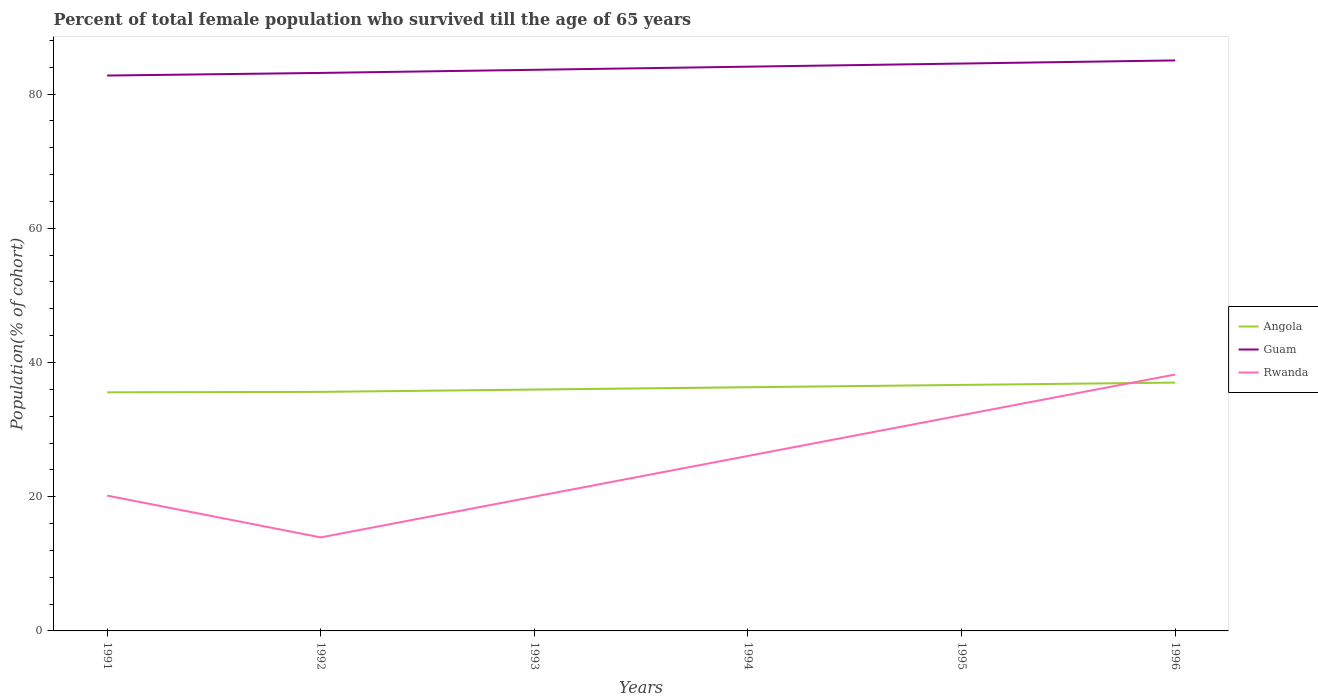Is the number of lines equal to the number of legend labels?
Ensure brevity in your answer.  Yes. Across all years, what is the maximum percentage of total female population who survived till the age of 65 years in Guam?
Your answer should be compact. 82.76. What is the total percentage of total female population who survived till the age of 65 years in Rwanda in the graph?
Your answer should be compact. 6.23. What is the difference between the highest and the second highest percentage of total female population who survived till the age of 65 years in Guam?
Ensure brevity in your answer.  2.25. What is the difference between the highest and the lowest percentage of total female population who survived till the age of 65 years in Rwanda?
Ensure brevity in your answer.  3. How many lines are there?
Offer a very short reply. 3. How many years are there in the graph?
Provide a succinct answer. 6. Are the values on the major ticks of Y-axis written in scientific E-notation?
Provide a short and direct response. No. How many legend labels are there?
Your response must be concise. 3. What is the title of the graph?
Offer a terse response. Percent of total female population who survived till the age of 65 years. What is the label or title of the Y-axis?
Give a very brief answer. Population(% of cohort). What is the Population(% of cohort) in Angola in 1991?
Provide a succinct answer. 35.56. What is the Population(% of cohort) in Guam in 1991?
Your answer should be very brief. 82.76. What is the Population(% of cohort) in Rwanda in 1991?
Offer a very short reply. 20.17. What is the Population(% of cohort) in Angola in 1992?
Offer a very short reply. 35.62. What is the Population(% of cohort) of Guam in 1992?
Your answer should be very brief. 83.16. What is the Population(% of cohort) of Rwanda in 1992?
Offer a very short reply. 13.94. What is the Population(% of cohort) in Angola in 1993?
Offer a terse response. 35.97. What is the Population(% of cohort) of Guam in 1993?
Keep it short and to the point. 83.62. What is the Population(% of cohort) in Rwanda in 1993?
Make the answer very short. 20.01. What is the Population(% of cohort) in Angola in 1994?
Your response must be concise. 36.32. What is the Population(% of cohort) in Guam in 1994?
Your response must be concise. 84.09. What is the Population(% of cohort) of Rwanda in 1994?
Offer a terse response. 26.08. What is the Population(% of cohort) in Angola in 1995?
Ensure brevity in your answer.  36.66. What is the Population(% of cohort) in Guam in 1995?
Your response must be concise. 84.55. What is the Population(% of cohort) in Rwanda in 1995?
Make the answer very short. 32.15. What is the Population(% of cohort) of Angola in 1996?
Give a very brief answer. 37.01. What is the Population(% of cohort) in Guam in 1996?
Ensure brevity in your answer.  85.02. What is the Population(% of cohort) of Rwanda in 1996?
Make the answer very short. 38.22. Across all years, what is the maximum Population(% of cohort) in Angola?
Make the answer very short. 37.01. Across all years, what is the maximum Population(% of cohort) in Guam?
Keep it short and to the point. 85.02. Across all years, what is the maximum Population(% of cohort) of Rwanda?
Ensure brevity in your answer.  38.22. Across all years, what is the minimum Population(% of cohort) of Angola?
Your answer should be compact. 35.56. Across all years, what is the minimum Population(% of cohort) of Guam?
Offer a very short reply. 82.76. Across all years, what is the minimum Population(% of cohort) of Rwanda?
Offer a terse response. 13.94. What is the total Population(% of cohort) of Angola in the graph?
Your answer should be very brief. 217.13. What is the total Population(% of cohort) of Guam in the graph?
Provide a succinct answer. 503.2. What is the total Population(% of cohort) of Rwanda in the graph?
Ensure brevity in your answer.  150.55. What is the difference between the Population(% of cohort) in Angola in 1991 and that in 1992?
Ensure brevity in your answer.  -0.07. What is the difference between the Population(% of cohort) of Guam in 1991 and that in 1992?
Give a very brief answer. -0.39. What is the difference between the Population(% of cohort) of Rwanda in 1991 and that in 1992?
Offer a very short reply. 6.23. What is the difference between the Population(% of cohort) of Angola in 1991 and that in 1993?
Offer a very short reply. -0.41. What is the difference between the Population(% of cohort) of Guam in 1991 and that in 1993?
Give a very brief answer. -0.86. What is the difference between the Population(% of cohort) in Rwanda in 1991 and that in 1993?
Offer a very short reply. 0.16. What is the difference between the Population(% of cohort) of Angola in 1991 and that in 1994?
Offer a terse response. -0.76. What is the difference between the Population(% of cohort) of Guam in 1991 and that in 1994?
Keep it short and to the point. -1.32. What is the difference between the Population(% of cohort) in Rwanda in 1991 and that in 1994?
Make the answer very short. -5.91. What is the difference between the Population(% of cohort) of Angola in 1991 and that in 1995?
Your response must be concise. -1.11. What is the difference between the Population(% of cohort) in Guam in 1991 and that in 1995?
Provide a short and direct response. -1.79. What is the difference between the Population(% of cohort) in Rwanda in 1991 and that in 1995?
Provide a short and direct response. -11.98. What is the difference between the Population(% of cohort) in Angola in 1991 and that in 1996?
Provide a succinct answer. -1.45. What is the difference between the Population(% of cohort) in Guam in 1991 and that in 1996?
Give a very brief answer. -2.25. What is the difference between the Population(% of cohort) in Rwanda in 1991 and that in 1996?
Make the answer very short. -18.05. What is the difference between the Population(% of cohort) of Angola in 1992 and that in 1993?
Offer a very short reply. -0.35. What is the difference between the Population(% of cohort) in Guam in 1992 and that in 1993?
Your answer should be compact. -0.47. What is the difference between the Population(% of cohort) of Rwanda in 1992 and that in 1993?
Make the answer very short. -6.07. What is the difference between the Population(% of cohort) in Angola in 1992 and that in 1994?
Your answer should be very brief. -0.69. What is the difference between the Population(% of cohort) of Guam in 1992 and that in 1994?
Give a very brief answer. -0.93. What is the difference between the Population(% of cohort) of Rwanda in 1992 and that in 1994?
Give a very brief answer. -12.14. What is the difference between the Population(% of cohort) in Angola in 1992 and that in 1995?
Your answer should be compact. -1.04. What is the difference between the Population(% of cohort) in Guam in 1992 and that in 1995?
Make the answer very short. -1.4. What is the difference between the Population(% of cohort) of Rwanda in 1992 and that in 1995?
Offer a terse response. -18.21. What is the difference between the Population(% of cohort) in Angola in 1992 and that in 1996?
Your answer should be compact. -1.38. What is the difference between the Population(% of cohort) in Guam in 1992 and that in 1996?
Offer a terse response. -1.86. What is the difference between the Population(% of cohort) of Rwanda in 1992 and that in 1996?
Provide a short and direct response. -24.28. What is the difference between the Population(% of cohort) of Angola in 1993 and that in 1994?
Your answer should be very brief. -0.35. What is the difference between the Population(% of cohort) in Guam in 1993 and that in 1994?
Offer a terse response. -0.47. What is the difference between the Population(% of cohort) of Rwanda in 1993 and that in 1994?
Give a very brief answer. -6.07. What is the difference between the Population(% of cohort) of Angola in 1993 and that in 1995?
Your answer should be compact. -0.69. What is the difference between the Population(% of cohort) in Guam in 1993 and that in 1995?
Offer a terse response. -0.93. What is the difference between the Population(% of cohort) in Rwanda in 1993 and that in 1995?
Make the answer very short. -12.14. What is the difference between the Population(% of cohort) of Angola in 1993 and that in 1996?
Keep it short and to the point. -1.04. What is the difference between the Population(% of cohort) in Guam in 1993 and that in 1996?
Provide a succinct answer. -1.4. What is the difference between the Population(% of cohort) in Rwanda in 1993 and that in 1996?
Make the answer very short. -18.21. What is the difference between the Population(% of cohort) in Angola in 1994 and that in 1995?
Keep it short and to the point. -0.35. What is the difference between the Population(% of cohort) in Guam in 1994 and that in 1995?
Offer a terse response. -0.47. What is the difference between the Population(% of cohort) of Rwanda in 1994 and that in 1995?
Make the answer very short. -6.07. What is the difference between the Population(% of cohort) in Angola in 1994 and that in 1996?
Your answer should be compact. -0.69. What is the difference between the Population(% of cohort) of Guam in 1994 and that in 1996?
Provide a succinct answer. -0.93. What is the difference between the Population(% of cohort) in Rwanda in 1994 and that in 1996?
Provide a succinct answer. -12.14. What is the difference between the Population(% of cohort) in Angola in 1995 and that in 1996?
Provide a succinct answer. -0.35. What is the difference between the Population(% of cohort) in Guam in 1995 and that in 1996?
Offer a very short reply. -0.47. What is the difference between the Population(% of cohort) in Rwanda in 1995 and that in 1996?
Keep it short and to the point. -6.07. What is the difference between the Population(% of cohort) of Angola in 1991 and the Population(% of cohort) of Guam in 1992?
Keep it short and to the point. -47.6. What is the difference between the Population(% of cohort) of Angola in 1991 and the Population(% of cohort) of Rwanda in 1992?
Ensure brevity in your answer.  21.62. What is the difference between the Population(% of cohort) in Guam in 1991 and the Population(% of cohort) in Rwanda in 1992?
Give a very brief answer. 68.83. What is the difference between the Population(% of cohort) of Angola in 1991 and the Population(% of cohort) of Guam in 1993?
Provide a succinct answer. -48.07. What is the difference between the Population(% of cohort) in Angola in 1991 and the Population(% of cohort) in Rwanda in 1993?
Your answer should be very brief. 15.55. What is the difference between the Population(% of cohort) of Guam in 1991 and the Population(% of cohort) of Rwanda in 1993?
Your answer should be compact. 62.76. What is the difference between the Population(% of cohort) in Angola in 1991 and the Population(% of cohort) in Guam in 1994?
Your answer should be compact. -48.53. What is the difference between the Population(% of cohort) of Angola in 1991 and the Population(% of cohort) of Rwanda in 1994?
Give a very brief answer. 9.48. What is the difference between the Population(% of cohort) of Guam in 1991 and the Population(% of cohort) of Rwanda in 1994?
Offer a terse response. 56.69. What is the difference between the Population(% of cohort) in Angola in 1991 and the Population(% of cohort) in Guam in 1995?
Your answer should be very brief. -49. What is the difference between the Population(% of cohort) in Angola in 1991 and the Population(% of cohort) in Rwanda in 1995?
Offer a terse response. 3.41. What is the difference between the Population(% of cohort) of Guam in 1991 and the Population(% of cohort) of Rwanda in 1995?
Keep it short and to the point. 50.62. What is the difference between the Population(% of cohort) of Angola in 1991 and the Population(% of cohort) of Guam in 1996?
Give a very brief answer. -49.46. What is the difference between the Population(% of cohort) of Angola in 1991 and the Population(% of cohort) of Rwanda in 1996?
Your answer should be compact. -2.66. What is the difference between the Population(% of cohort) in Guam in 1991 and the Population(% of cohort) in Rwanda in 1996?
Offer a terse response. 44.55. What is the difference between the Population(% of cohort) of Angola in 1992 and the Population(% of cohort) of Guam in 1993?
Make the answer very short. -48. What is the difference between the Population(% of cohort) in Angola in 1992 and the Population(% of cohort) in Rwanda in 1993?
Offer a very short reply. 15.62. What is the difference between the Population(% of cohort) of Guam in 1992 and the Population(% of cohort) of Rwanda in 1993?
Your response must be concise. 63.15. What is the difference between the Population(% of cohort) in Angola in 1992 and the Population(% of cohort) in Guam in 1994?
Your answer should be very brief. -48.46. What is the difference between the Population(% of cohort) of Angola in 1992 and the Population(% of cohort) of Rwanda in 1994?
Your answer should be compact. 9.55. What is the difference between the Population(% of cohort) of Guam in 1992 and the Population(% of cohort) of Rwanda in 1994?
Offer a terse response. 57.08. What is the difference between the Population(% of cohort) of Angola in 1992 and the Population(% of cohort) of Guam in 1995?
Provide a succinct answer. -48.93. What is the difference between the Population(% of cohort) of Angola in 1992 and the Population(% of cohort) of Rwanda in 1995?
Keep it short and to the point. 3.48. What is the difference between the Population(% of cohort) in Guam in 1992 and the Population(% of cohort) in Rwanda in 1995?
Offer a very short reply. 51.01. What is the difference between the Population(% of cohort) of Angola in 1992 and the Population(% of cohort) of Guam in 1996?
Ensure brevity in your answer.  -49.39. What is the difference between the Population(% of cohort) in Angola in 1992 and the Population(% of cohort) in Rwanda in 1996?
Provide a succinct answer. -2.59. What is the difference between the Population(% of cohort) in Guam in 1992 and the Population(% of cohort) in Rwanda in 1996?
Offer a terse response. 44.94. What is the difference between the Population(% of cohort) in Angola in 1993 and the Population(% of cohort) in Guam in 1994?
Offer a terse response. -48.12. What is the difference between the Population(% of cohort) in Angola in 1993 and the Population(% of cohort) in Rwanda in 1994?
Your answer should be very brief. 9.89. What is the difference between the Population(% of cohort) of Guam in 1993 and the Population(% of cohort) of Rwanda in 1994?
Give a very brief answer. 57.54. What is the difference between the Population(% of cohort) in Angola in 1993 and the Population(% of cohort) in Guam in 1995?
Provide a succinct answer. -48.58. What is the difference between the Population(% of cohort) of Angola in 1993 and the Population(% of cohort) of Rwanda in 1995?
Offer a terse response. 3.82. What is the difference between the Population(% of cohort) of Guam in 1993 and the Population(% of cohort) of Rwanda in 1995?
Give a very brief answer. 51.47. What is the difference between the Population(% of cohort) of Angola in 1993 and the Population(% of cohort) of Guam in 1996?
Give a very brief answer. -49.05. What is the difference between the Population(% of cohort) in Angola in 1993 and the Population(% of cohort) in Rwanda in 1996?
Offer a terse response. -2.25. What is the difference between the Population(% of cohort) of Guam in 1993 and the Population(% of cohort) of Rwanda in 1996?
Your answer should be very brief. 45.41. What is the difference between the Population(% of cohort) in Angola in 1994 and the Population(% of cohort) in Guam in 1995?
Your response must be concise. -48.24. What is the difference between the Population(% of cohort) of Angola in 1994 and the Population(% of cohort) of Rwanda in 1995?
Offer a very short reply. 4.17. What is the difference between the Population(% of cohort) in Guam in 1994 and the Population(% of cohort) in Rwanda in 1995?
Provide a succinct answer. 51.94. What is the difference between the Population(% of cohort) in Angola in 1994 and the Population(% of cohort) in Guam in 1996?
Ensure brevity in your answer.  -48.7. What is the difference between the Population(% of cohort) in Angola in 1994 and the Population(% of cohort) in Rwanda in 1996?
Give a very brief answer. -1.9. What is the difference between the Population(% of cohort) of Guam in 1994 and the Population(% of cohort) of Rwanda in 1996?
Provide a succinct answer. 45.87. What is the difference between the Population(% of cohort) in Angola in 1995 and the Population(% of cohort) in Guam in 1996?
Offer a terse response. -48.36. What is the difference between the Population(% of cohort) of Angola in 1995 and the Population(% of cohort) of Rwanda in 1996?
Offer a terse response. -1.55. What is the difference between the Population(% of cohort) of Guam in 1995 and the Population(% of cohort) of Rwanda in 1996?
Your answer should be compact. 46.34. What is the average Population(% of cohort) of Angola per year?
Your response must be concise. 36.19. What is the average Population(% of cohort) of Guam per year?
Keep it short and to the point. 83.87. What is the average Population(% of cohort) of Rwanda per year?
Offer a very short reply. 25.09. In the year 1991, what is the difference between the Population(% of cohort) in Angola and Population(% of cohort) in Guam?
Provide a succinct answer. -47.21. In the year 1991, what is the difference between the Population(% of cohort) in Angola and Population(% of cohort) in Rwanda?
Offer a terse response. 15.39. In the year 1991, what is the difference between the Population(% of cohort) of Guam and Population(% of cohort) of Rwanda?
Make the answer very short. 62.6. In the year 1992, what is the difference between the Population(% of cohort) in Angola and Population(% of cohort) in Guam?
Offer a very short reply. -47.53. In the year 1992, what is the difference between the Population(% of cohort) in Angola and Population(% of cohort) in Rwanda?
Ensure brevity in your answer.  21.69. In the year 1992, what is the difference between the Population(% of cohort) of Guam and Population(% of cohort) of Rwanda?
Your answer should be compact. 69.22. In the year 1993, what is the difference between the Population(% of cohort) in Angola and Population(% of cohort) in Guam?
Make the answer very short. -47.65. In the year 1993, what is the difference between the Population(% of cohort) of Angola and Population(% of cohort) of Rwanda?
Offer a very short reply. 15.96. In the year 1993, what is the difference between the Population(% of cohort) in Guam and Population(% of cohort) in Rwanda?
Provide a succinct answer. 63.61. In the year 1994, what is the difference between the Population(% of cohort) in Angola and Population(% of cohort) in Guam?
Make the answer very short. -47.77. In the year 1994, what is the difference between the Population(% of cohort) in Angola and Population(% of cohort) in Rwanda?
Keep it short and to the point. 10.24. In the year 1994, what is the difference between the Population(% of cohort) in Guam and Population(% of cohort) in Rwanda?
Your answer should be compact. 58.01. In the year 1995, what is the difference between the Population(% of cohort) in Angola and Population(% of cohort) in Guam?
Make the answer very short. -47.89. In the year 1995, what is the difference between the Population(% of cohort) of Angola and Population(% of cohort) of Rwanda?
Ensure brevity in your answer.  4.51. In the year 1995, what is the difference between the Population(% of cohort) of Guam and Population(% of cohort) of Rwanda?
Your answer should be compact. 52.41. In the year 1996, what is the difference between the Population(% of cohort) in Angola and Population(% of cohort) in Guam?
Offer a terse response. -48.01. In the year 1996, what is the difference between the Population(% of cohort) of Angola and Population(% of cohort) of Rwanda?
Make the answer very short. -1.21. In the year 1996, what is the difference between the Population(% of cohort) in Guam and Population(% of cohort) in Rwanda?
Give a very brief answer. 46.8. What is the ratio of the Population(% of cohort) in Rwanda in 1991 to that in 1992?
Offer a terse response. 1.45. What is the ratio of the Population(% of cohort) in Angola in 1991 to that in 1993?
Keep it short and to the point. 0.99. What is the ratio of the Population(% of cohort) of Rwanda in 1991 to that in 1993?
Ensure brevity in your answer.  1.01. What is the ratio of the Population(% of cohort) of Angola in 1991 to that in 1994?
Provide a short and direct response. 0.98. What is the ratio of the Population(% of cohort) in Guam in 1991 to that in 1994?
Your answer should be very brief. 0.98. What is the ratio of the Population(% of cohort) in Rwanda in 1991 to that in 1994?
Offer a very short reply. 0.77. What is the ratio of the Population(% of cohort) in Angola in 1991 to that in 1995?
Offer a terse response. 0.97. What is the ratio of the Population(% of cohort) of Guam in 1991 to that in 1995?
Offer a very short reply. 0.98. What is the ratio of the Population(% of cohort) in Rwanda in 1991 to that in 1995?
Offer a very short reply. 0.63. What is the ratio of the Population(% of cohort) of Angola in 1991 to that in 1996?
Your answer should be very brief. 0.96. What is the ratio of the Population(% of cohort) of Guam in 1991 to that in 1996?
Keep it short and to the point. 0.97. What is the ratio of the Population(% of cohort) in Rwanda in 1991 to that in 1996?
Offer a terse response. 0.53. What is the ratio of the Population(% of cohort) in Angola in 1992 to that in 1993?
Ensure brevity in your answer.  0.99. What is the ratio of the Population(% of cohort) in Guam in 1992 to that in 1993?
Keep it short and to the point. 0.99. What is the ratio of the Population(% of cohort) in Rwanda in 1992 to that in 1993?
Provide a succinct answer. 0.7. What is the ratio of the Population(% of cohort) in Angola in 1992 to that in 1994?
Your response must be concise. 0.98. What is the ratio of the Population(% of cohort) of Guam in 1992 to that in 1994?
Provide a short and direct response. 0.99. What is the ratio of the Population(% of cohort) of Rwanda in 1992 to that in 1994?
Provide a short and direct response. 0.53. What is the ratio of the Population(% of cohort) in Angola in 1992 to that in 1995?
Keep it short and to the point. 0.97. What is the ratio of the Population(% of cohort) in Guam in 1992 to that in 1995?
Your response must be concise. 0.98. What is the ratio of the Population(% of cohort) in Rwanda in 1992 to that in 1995?
Your answer should be very brief. 0.43. What is the ratio of the Population(% of cohort) of Angola in 1992 to that in 1996?
Keep it short and to the point. 0.96. What is the ratio of the Population(% of cohort) of Guam in 1992 to that in 1996?
Your answer should be very brief. 0.98. What is the ratio of the Population(% of cohort) in Rwanda in 1992 to that in 1996?
Make the answer very short. 0.36. What is the ratio of the Population(% of cohort) of Rwanda in 1993 to that in 1994?
Your answer should be very brief. 0.77. What is the ratio of the Population(% of cohort) of Angola in 1993 to that in 1995?
Offer a terse response. 0.98. What is the ratio of the Population(% of cohort) of Guam in 1993 to that in 1995?
Provide a succinct answer. 0.99. What is the ratio of the Population(% of cohort) in Rwanda in 1993 to that in 1995?
Offer a terse response. 0.62. What is the ratio of the Population(% of cohort) in Guam in 1993 to that in 1996?
Your answer should be compact. 0.98. What is the ratio of the Population(% of cohort) of Rwanda in 1993 to that in 1996?
Keep it short and to the point. 0.52. What is the ratio of the Population(% of cohort) of Angola in 1994 to that in 1995?
Provide a succinct answer. 0.99. What is the ratio of the Population(% of cohort) of Rwanda in 1994 to that in 1995?
Your answer should be compact. 0.81. What is the ratio of the Population(% of cohort) of Angola in 1994 to that in 1996?
Ensure brevity in your answer.  0.98. What is the ratio of the Population(% of cohort) of Rwanda in 1994 to that in 1996?
Make the answer very short. 0.68. What is the ratio of the Population(% of cohort) in Angola in 1995 to that in 1996?
Keep it short and to the point. 0.99. What is the ratio of the Population(% of cohort) in Rwanda in 1995 to that in 1996?
Your response must be concise. 0.84. What is the difference between the highest and the second highest Population(% of cohort) in Angola?
Your answer should be very brief. 0.35. What is the difference between the highest and the second highest Population(% of cohort) of Guam?
Offer a terse response. 0.47. What is the difference between the highest and the second highest Population(% of cohort) in Rwanda?
Provide a succinct answer. 6.07. What is the difference between the highest and the lowest Population(% of cohort) in Angola?
Provide a short and direct response. 1.45. What is the difference between the highest and the lowest Population(% of cohort) of Guam?
Ensure brevity in your answer.  2.25. What is the difference between the highest and the lowest Population(% of cohort) in Rwanda?
Offer a terse response. 24.28. 